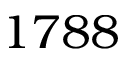<formula> <loc_0><loc_0><loc_500><loc_500>1 7 8 8</formula> 